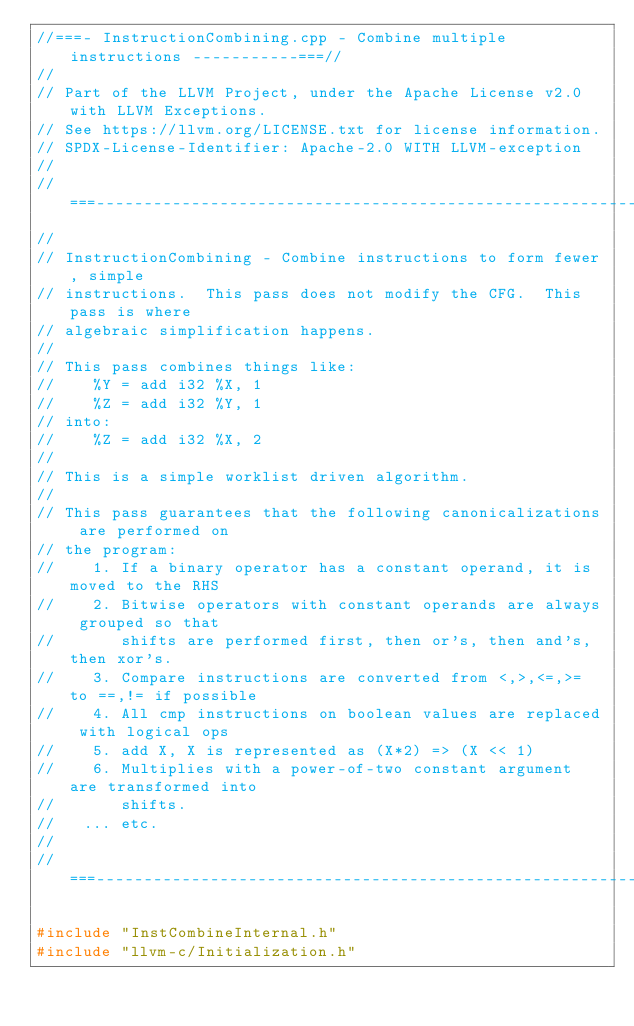<code> <loc_0><loc_0><loc_500><loc_500><_C++_>//===- InstructionCombining.cpp - Combine multiple instructions -----------===//
//
// Part of the LLVM Project, under the Apache License v2.0 with LLVM Exceptions.
// See https://llvm.org/LICENSE.txt for license information.
// SPDX-License-Identifier: Apache-2.0 WITH LLVM-exception
//
//===----------------------------------------------------------------------===//
//
// InstructionCombining - Combine instructions to form fewer, simple
// instructions.  This pass does not modify the CFG.  This pass is where
// algebraic simplification happens.
//
// This pass combines things like:
//    %Y = add i32 %X, 1
//    %Z = add i32 %Y, 1
// into:
//    %Z = add i32 %X, 2
//
// This is a simple worklist driven algorithm.
//
// This pass guarantees that the following canonicalizations are performed on
// the program:
//    1. If a binary operator has a constant operand, it is moved to the RHS
//    2. Bitwise operators with constant operands are always grouped so that
//       shifts are performed first, then or's, then and's, then xor's.
//    3. Compare instructions are converted from <,>,<=,>= to ==,!= if possible
//    4. All cmp instructions on boolean values are replaced with logical ops
//    5. add X, X is represented as (X*2) => (X << 1)
//    6. Multiplies with a power-of-two constant argument are transformed into
//       shifts.
//   ... etc.
//
//===----------------------------------------------------------------------===//

#include "InstCombineInternal.h"
#include "llvm-c/Initialization.h"</code> 